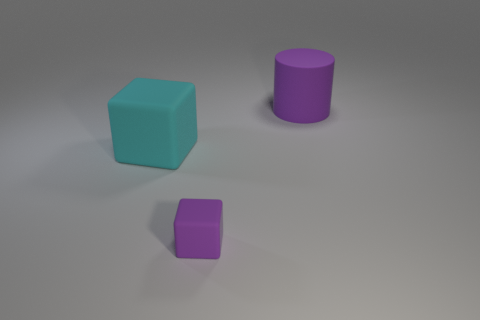Are there any other things that have the same size as the purple block?
Ensure brevity in your answer.  No. Are there any matte cylinders?
Make the answer very short. Yes. What number of rubber cylinders have the same color as the tiny cube?
Offer a very short reply. 1. There is a large cylinder that is the same color as the small rubber cube; what is its material?
Keep it short and to the point. Rubber. There is a object that is to the right of the matte block in front of the cyan block; what size is it?
Your response must be concise. Large. Are there any big purple balls made of the same material as the large block?
Keep it short and to the point. No. There is a purple object that is the same size as the cyan rubber object; what is it made of?
Keep it short and to the point. Rubber. Does the large rubber thing that is right of the small purple matte thing have the same color as the tiny thing in front of the large cylinder?
Provide a short and direct response. Yes. There is a purple rubber thing on the right side of the tiny matte object; are there any big purple objects right of it?
Make the answer very short. No. Do the purple rubber thing that is in front of the big purple matte object and the big thing right of the small purple thing have the same shape?
Offer a terse response. No. 